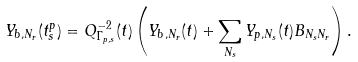Convert formula to latex. <formula><loc_0><loc_0><loc_500><loc_500>Y _ { b , N _ { r } } ( t _ { s } ^ { p } ) = Q _ { \Gamma _ { p , s } } ^ { - 2 } ( t ) \left ( Y _ { b , N _ { r } } ( t ) + \sum _ { N _ { s } } Y _ { p , N _ { s } } ( t ) B _ { N _ { s } N _ { r } } \right ) .</formula> 